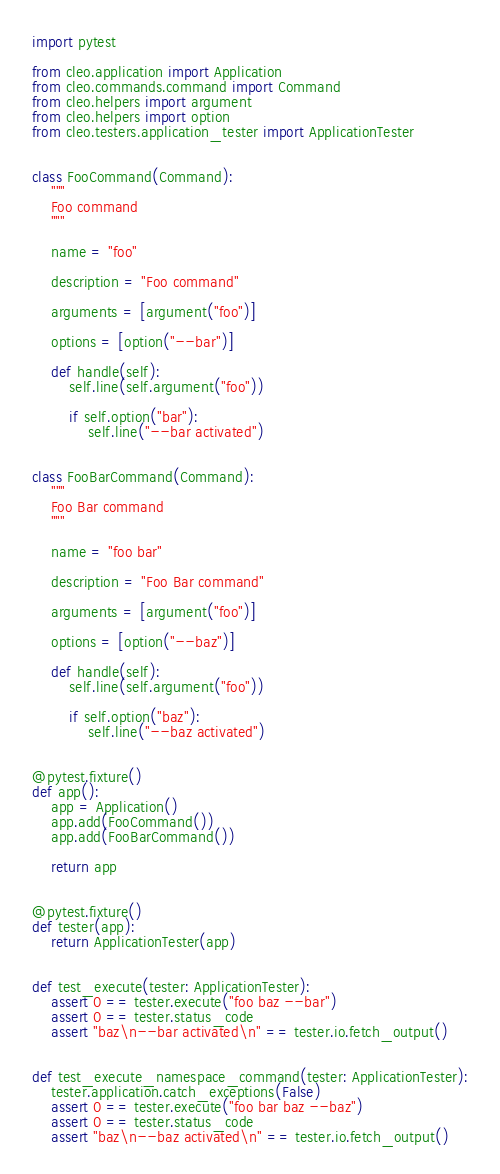<code> <loc_0><loc_0><loc_500><loc_500><_Python_>import pytest

from cleo.application import Application
from cleo.commands.command import Command
from cleo.helpers import argument
from cleo.helpers import option
from cleo.testers.application_tester import ApplicationTester


class FooCommand(Command):
    """
    Foo command
    """

    name = "foo"

    description = "Foo command"

    arguments = [argument("foo")]

    options = [option("--bar")]

    def handle(self):
        self.line(self.argument("foo"))

        if self.option("bar"):
            self.line("--bar activated")


class FooBarCommand(Command):
    """
    Foo Bar command
    """

    name = "foo bar"

    description = "Foo Bar command"

    arguments = [argument("foo")]

    options = [option("--baz")]

    def handle(self):
        self.line(self.argument("foo"))

        if self.option("baz"):
            self.line("--baz activated")


@pytest.fixture()
def app():
    app = Application()
    app.add(FooCommand())
    app.add(FooBarCommand())

    return app


@pytest.fixture()
def tester(app):
    return ApplicationTester(app)


def test_execute(tester: ApplicationTester):
    assert 0 == tester.execute("foo baz --bar")
    assert 0 == tester.status_code
    assert "baz\n--bar activated\n" == tester.io.fetch_output()


def test_execute_namespace_command(tester: ApplicationTester):
    tester.application.catch_exceptions(False)
    assert 0 == tester.execute("foo bar baz --baz")
    assert 0 == tester.status_code
    assert "baz\n--baz activated\n" == tester.io.fetch_output()
</code> 